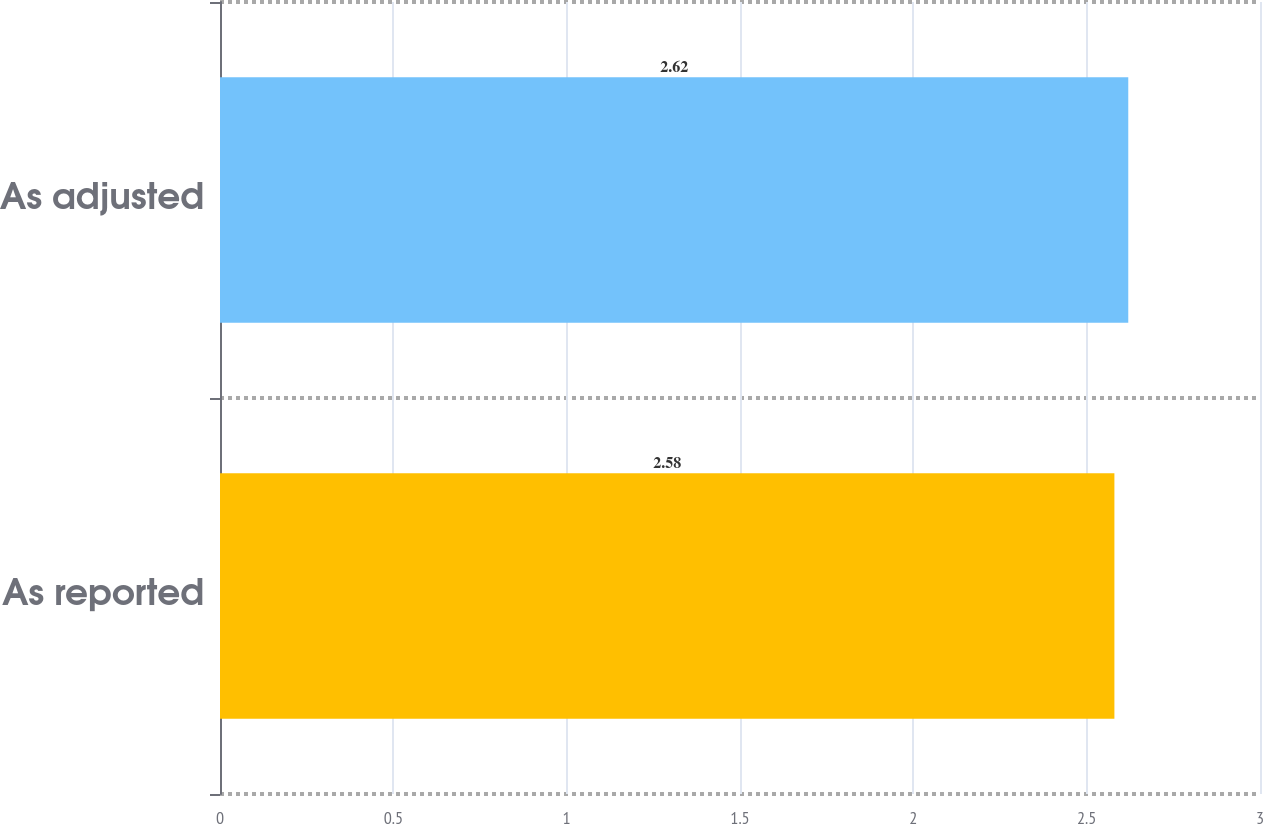Convert chart to OTSL. <chart><loc_0><loc_0><loc_500><loc_500><bar_chart><fcel>As reported<fcel>As adjusted<nl><fcel>2.58<fcel>2.62<nl></chart> 